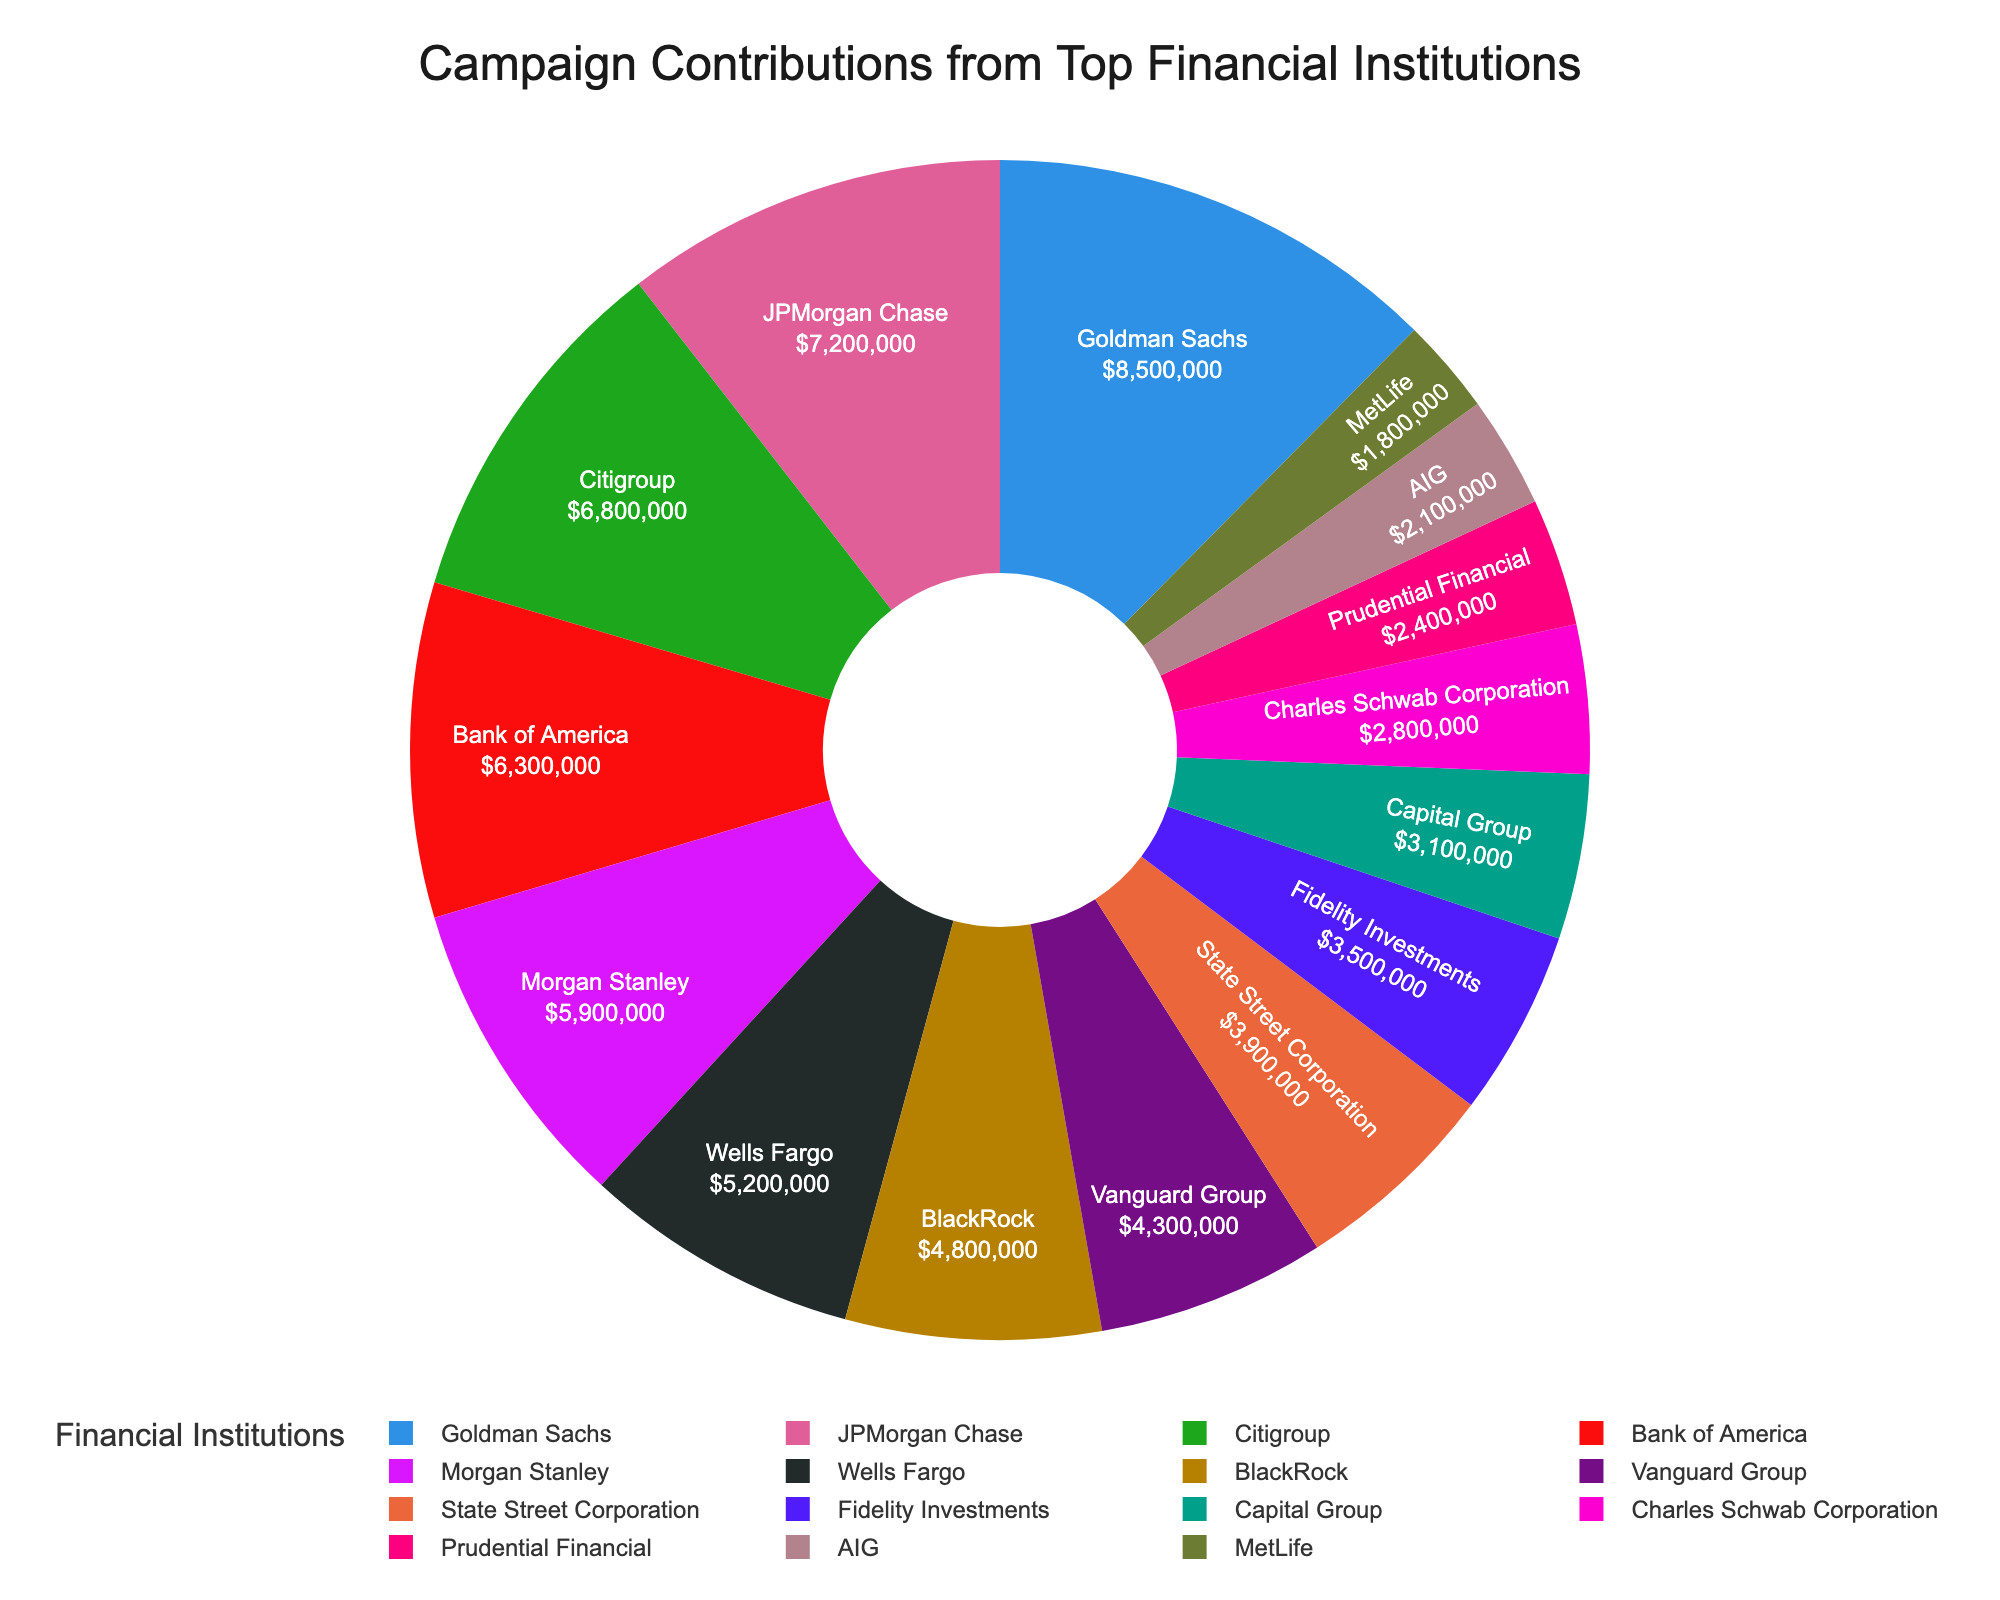Which financial institution made the highest campaign contributions? By referring to the figure, we identify the segment of the pie chart with the largest area. This segment corresponds to Goldman Sachs.
Answer: Goldman Sachs What's the total amount contributed by JPMorgan Chase and Citigroup? Sum the individual contributions of JPMorgan Chase ($7,200,000) and Citigroup ($6,800,000). Adding these amounts gives $7,200,000 + $6,800,000 = $14,000,000.
Answer: $14,000,000 How does the campaign contribution of BlackRock compare to that of Wells Fargo? Compare the amounts contributed by BlackRock ($4,800,000) and Wells Fargo ($5,200,000). Wells Fargo's contribution is greater than BlackRock's.
Answer: Wells Fargo's contribution is greater What percentage of the total contributions is made by Bank of America? First, we determine the total contributions by summing all provided amounts. Total = $8,500,000 + $7,200,000 + $6,800,000 + $6,300,000 + $5,900,000 + $5,200,000 + $4,800,000 + $4,300,000 + $3,900,000 + $3,500,000 + $3,100,000 + $2,800,000 + $2,400,000 + $2,100,000 + $1,800,000 = $68,600,000. Bank of America's contribution is $6,300,000. Percent = ($6,300,000 / $68,600,000) * 100 ≈ 9.18%.
Answer: Approximately 9.18% Which institution contributed the least, and what is the amount? By examining the smallest segment of the pie chart, we find it corresponds to MetLife, with a contribution of $1,800,000.
Answer: MetLife, $1,800,000 What is the combined amount contributed by the institutions with contributions greater than $5,000,000? Identify the institutions and their contributions: Goldman Sachs ($8,500,000), JPMorgan Chase ($7,200,000), Citigroup ($6,800,000), Bank of America ($6,300,000), Morgan Stanley ($5,900,000), and Wells Fargo ($5,200,000). Sum these contributions: $8,500,000 + $7,200,000 + $6,800,000 + $6,300,000 + $5,900,000 + $5,200,000 = $39,900,000.
Answer: $39,900,000 What is the difference in contributions between State Street Corporation and Fidelity Investments? Subtract the contribution of Fidelity Investments ($3,500,000) from State Street Corporation ($3,900,000), resulting in a difference of $3,900,000 - $3,500,000 = $400,000.
Answer: $400,000 Which institutions' contributions together form approximately one-third of the total contributions? We need contributions totaling approximately one-third of the total ($68,600,000 / 3 ≈ $22,867,000). Summing contributions: Goldman Sachs ($8,500,000) + JPMorgan Chase ($7,200,000) + Citigroup ($6,800,000) = $22,500,000, which is close to one-third of the total.
Answer: Goldman Sachs, JPMorgan Chase, Citigroup 